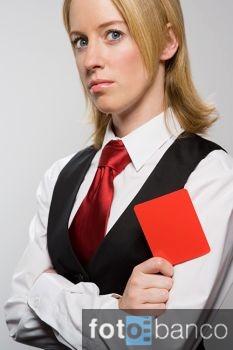Who owns this photo?
Give a very brief answer. Fotobanco. Is one of her hands tucked?
Answer briefly. Yes. What kind of knot is tied in this tie?
Be succinct. Windsor. 